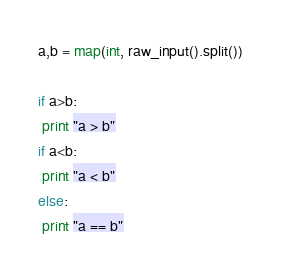<code> <loc_0><loc_0><loc_500><loc_500><_Python_>a,b = map(int, raw_input().split())

if a>b:
 print "a > b"
if a<b:
 print "a < b"
else:
 print "a == b"</code> 